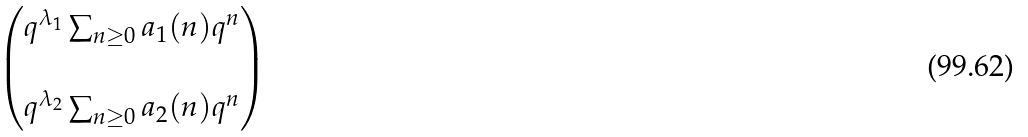Convert formula to latex. <formula><loc_0><loc_0><loc_500><loc_500>\begin{pmatrix} q ^ { \lambda _ { 1 } } \sum _ { n \geq 0 } a _ { 1 } ( n ) q ^ { n } \\ \\ q ^ { \lambda _ { 2 } } \sum _ { n \geq 0 } a _ { 2 } ( n ) q ^ { n } \end{pmatrix}</formula> 